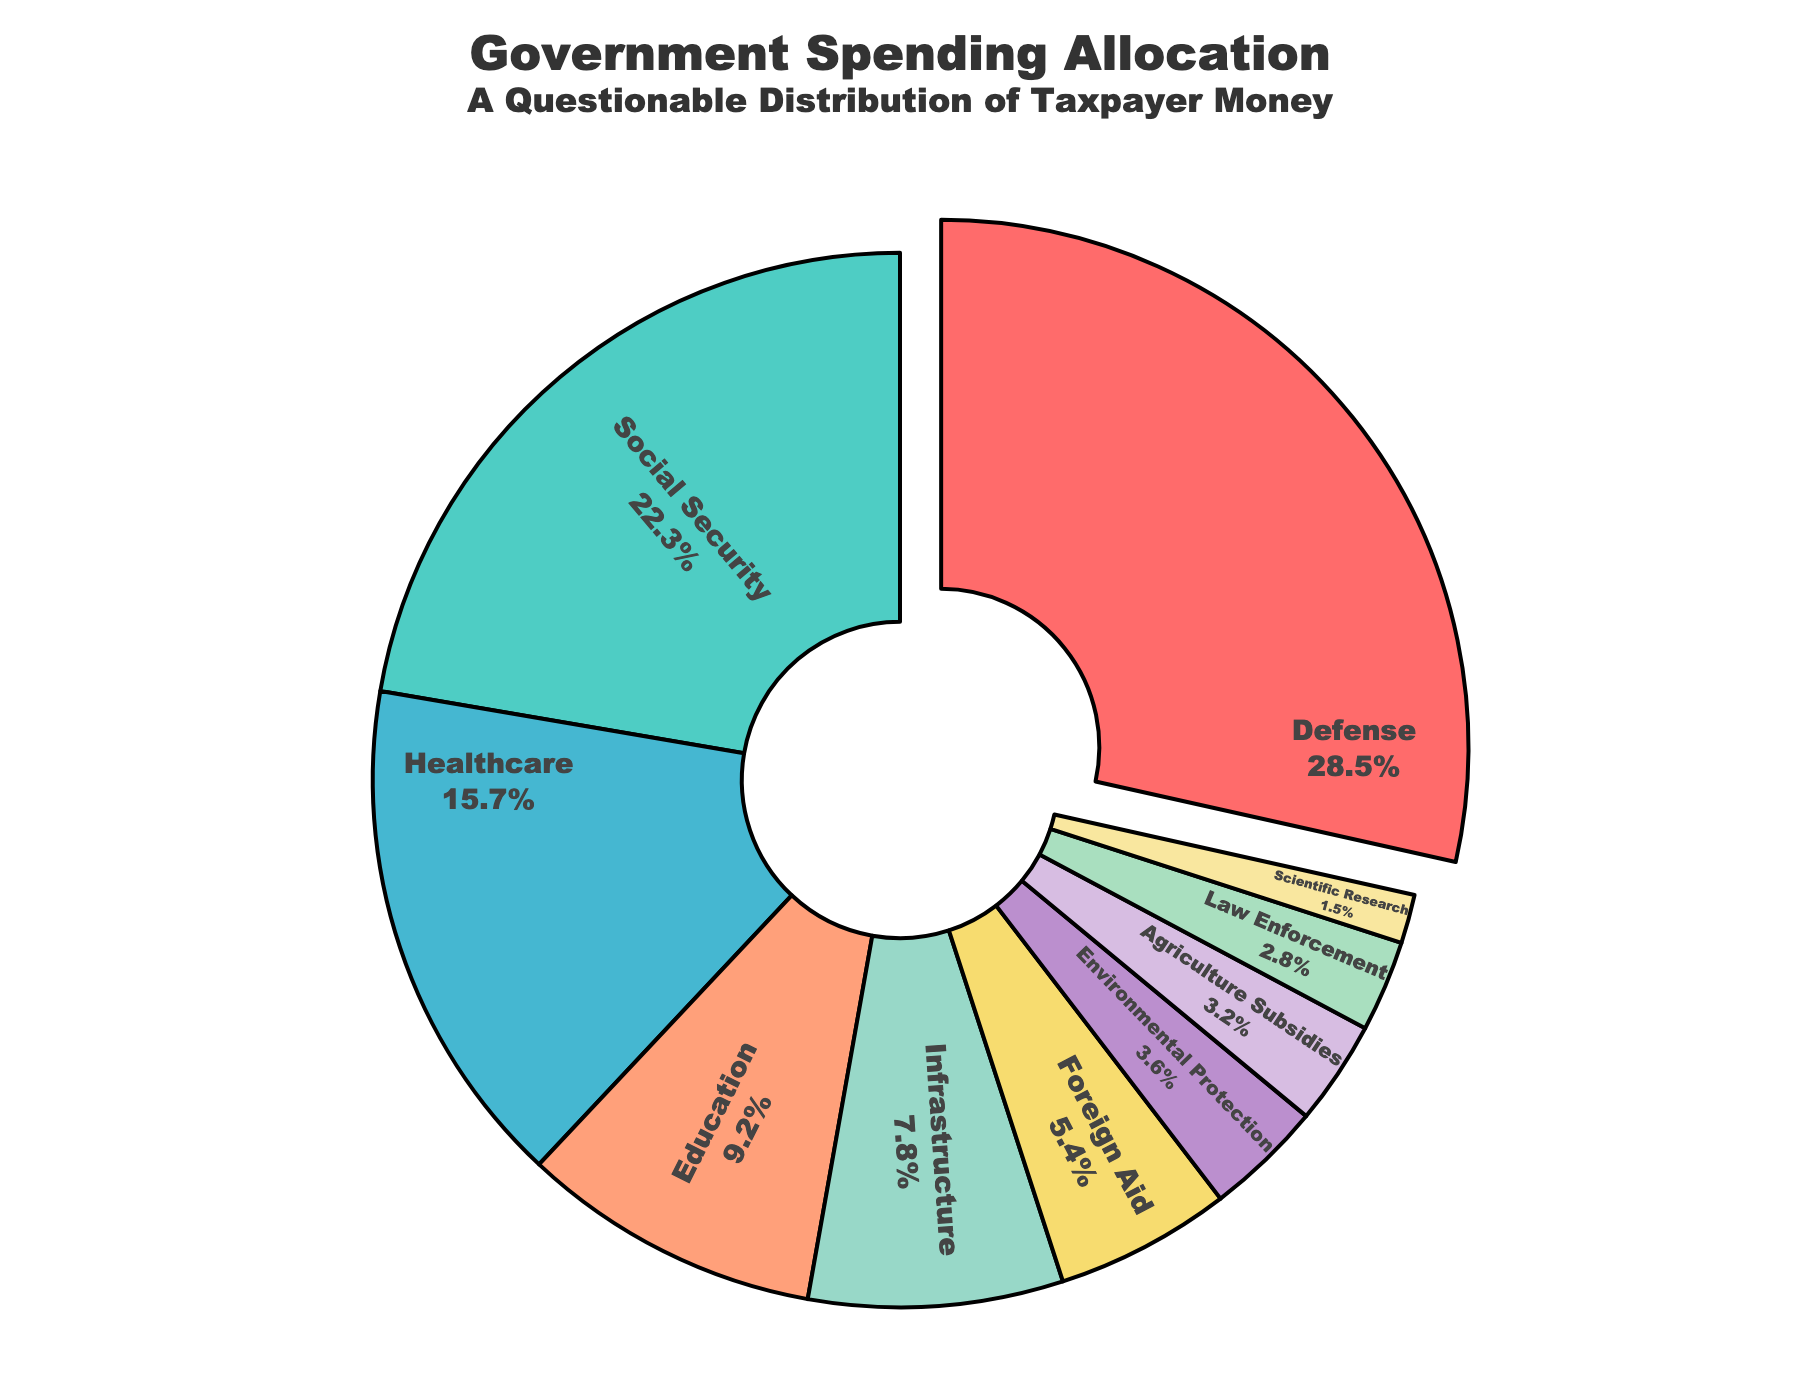Which sector receives the highest percentage of government spending? The largest segment of the pie chart is labeled "Defense," which occupies more space than any other segment.
Answer: Defense Which sectors combined receive a higher percentage of government spending than Healthcare alone? Healthcare receives 15.7%. Sectors like Environmental Protection (3.6%), Agriculture Subsidies (3.2%), Law Enforcement (2.8%), and Scientific Research (1.5%) combined exceed this amount when summed (3.6 + 3.2 + 2.8 + 1.5 = 11.1). Adding Foreign Aid (5.4) makes it 16.5, which is higher than 15.7.
Answer: Environmental Protection, Agriculture Subsidies, Law Enforcement, Scientific Research, and Foreign Aid What is the difference in spending percentage between Social Security and Education? Social Security is 22.3% and Education is 9.2%. The difference is 22.3 - 9.2.
Answer: 13.1 Which sectors have a spending percentage less than 5%? The segments labeled Foreign Aid (5.4%), Environmental Protection (3.6%), Agriculture Subsidies (3.2%), Law Enforcement (2.8%), and Scientific Research (1.5%) all have percentages less than 5%, except Foreign Aid which is slightly above.
Answer: Environmental Protection, Agriculture Subsidies, Law Enforcement, Scientific Research If funding for Infrastructure and Agriculture Subsidies are combined, would it exceed the funding for Education? Infrastructure is 7.8% and Agriculture Subsidies is 3.2%. Combined, they total 7.8 + 3.2 = 11, which is greater than Education's 9.2%.
Answer: Yes What is the cumulative percentage of spending on Environmental Protection, Agriculture Subsidies, and Law Enforcement? Adding the percentages of Environmental Protection (3.6%), Agriculture Subsidies (3.2%), and Law Enforcement (2.8%) gives 3.6 + 3.2 + 2.8.
Answer: 9.6 Which visual indicator highlights the sector with the highest spending? The slice representing Defense is slightly separated from the rest of the pie chart, indicating it as the highest spending sector.
Answer: Defense How does spending on Foreign Aid compare to the combined spending on Law Enforcement and Scientific Research? Foreign Aid is 5.4%. Law Enforcement and Scientific Research combined are 2.8 + 1.5 = 4.3%. 5.4 is greater than 4.3.
Answer: Higher What is the combined spending percentage on Defense and Social Security? Defense is 28.5% and Social Security is 22.3%. Adding these together gives 28.5 + 22.3.
Answer: 50.8 What percentage of spending is allocated across sectors labeled with shades of purple? The sectors in shades of purple are Environmental Protection (3.6%) and Scientific Research (1.5%). Adding these gives 3.6 + 1.5.
Answer: 5.1 